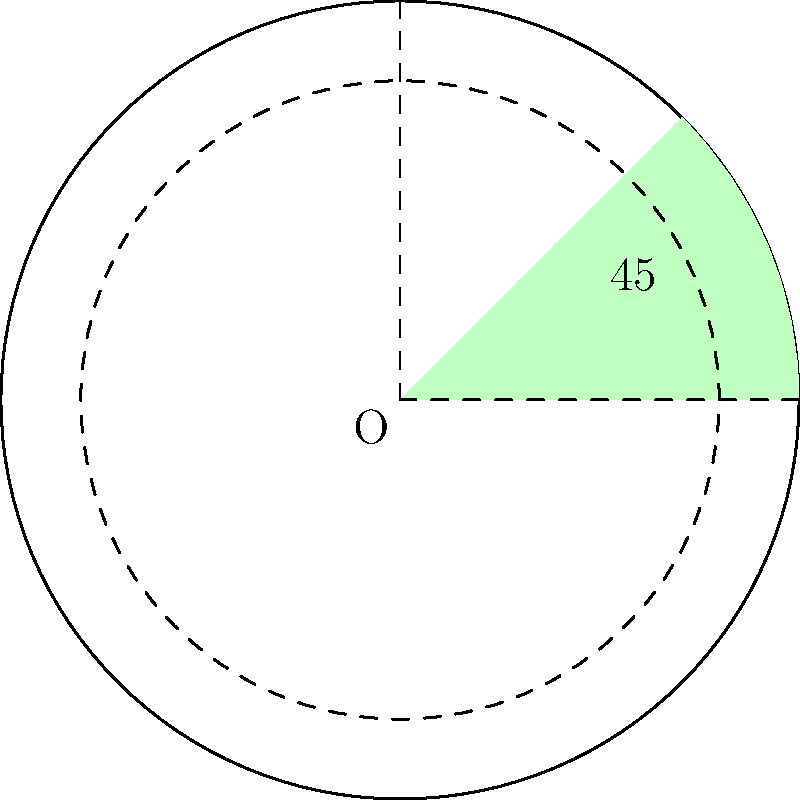In the circular garden, there's a special pie-shaped section for growing flowers. If this section takes up $\frac{1}{8}$ of the whole garden, what is the central angle of this flower section in degrees? Let's think about this step-by-step:

1. Remember that a full circle has 360°.

2. We're told that the flower section is $\frac{1}{8}$ of the whole garden.

3. To find the angle of this section, we need to divide the total degrees in a circle by 8:

   $$\frac{360°}{8} = 45°$$

4. This means that $\frac{1}{8}$ of the circle is 45°.

5. In the diagram, we can see that the green section represents this $\frac{1}{8}$ part, and it's labeled with a 45° angle.

So, the central angle of the pie-shaped flower section is 45°.
Answer: 45° 